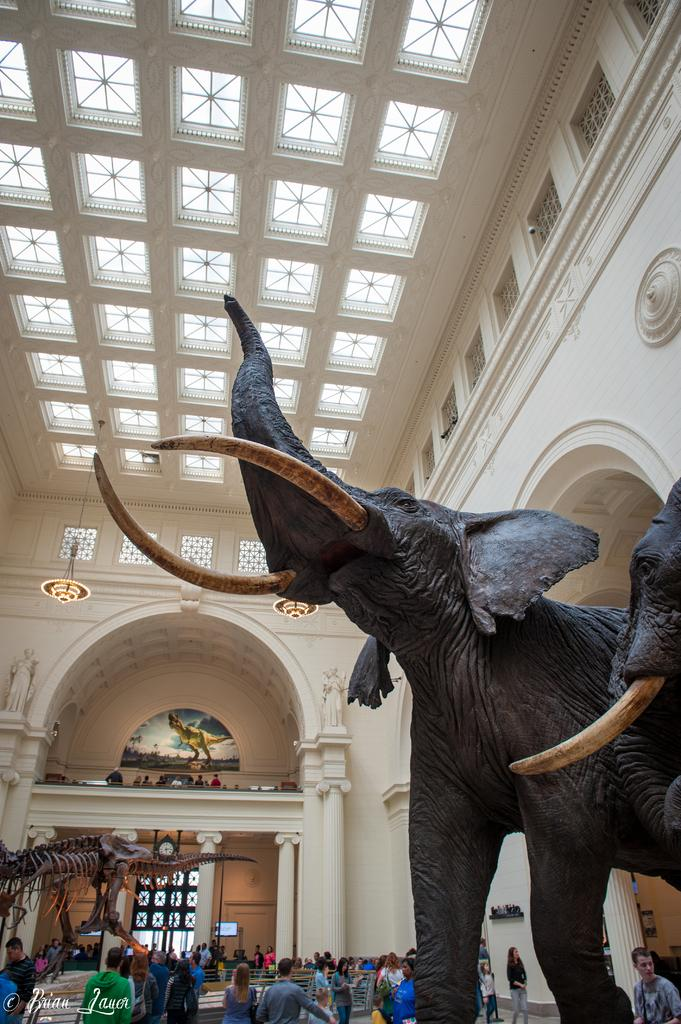What type of sculpture is in the image? There is a sculpture of an elephant in the image. Where is the sculpture located in the image? The sculpture is on the right side of the image. Who else is present in the image besides the sculpture? There are people standing in the image. Where are the people located in the image? The people are at the bottom of the image. What can be seen in the background of the image? There is a building in the background of the image. How many boys are sitting in the middle of the image? There are no boys present in the image, and it does not show any sitting positions. 